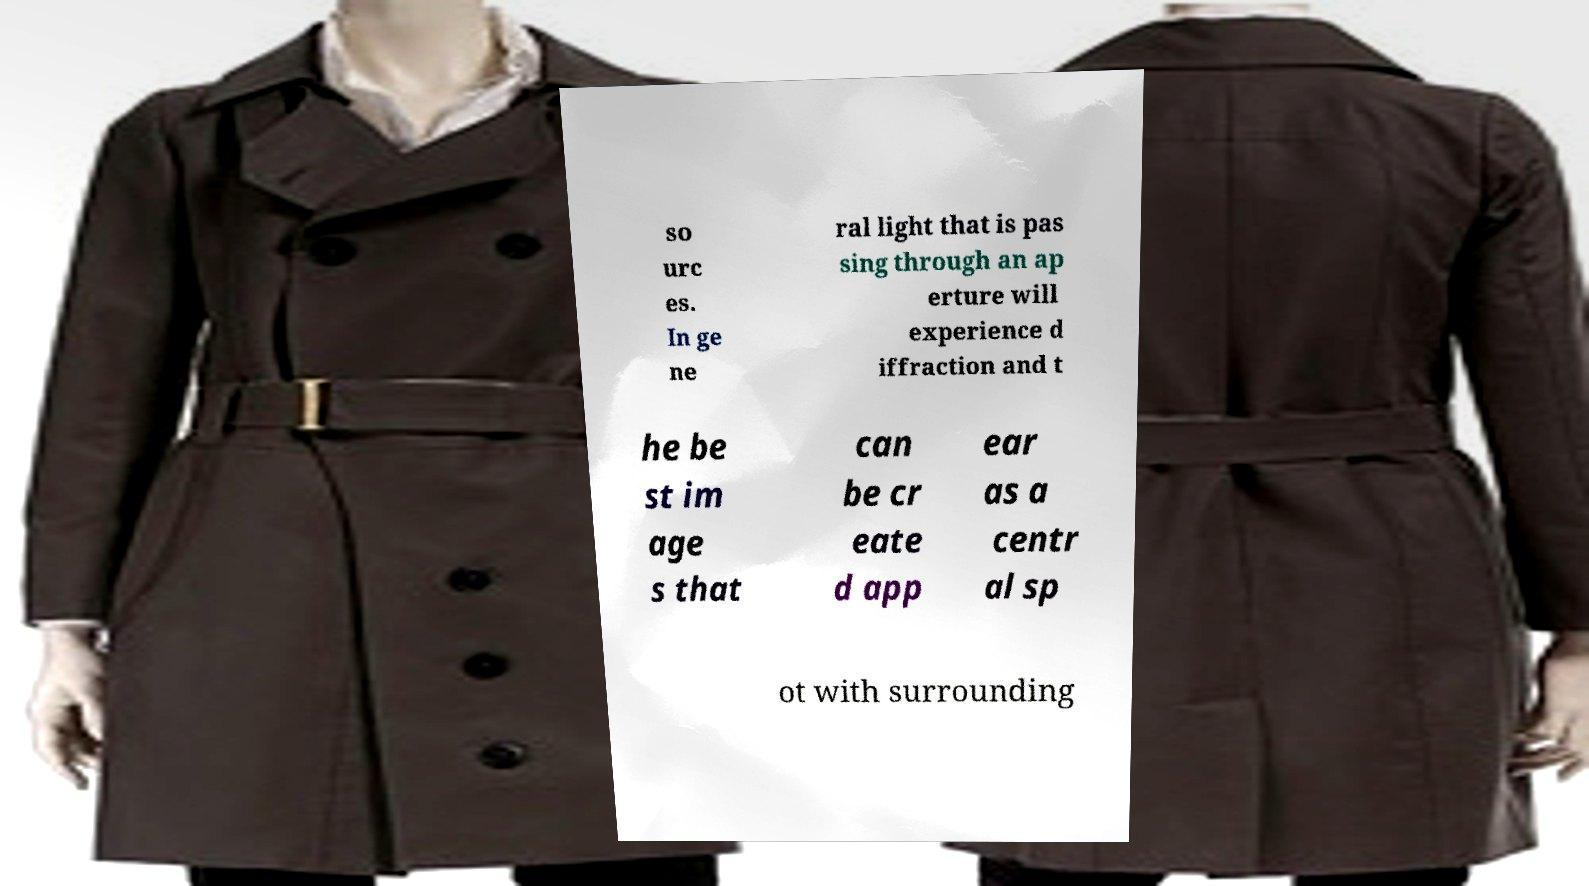For documentation purposes, I need the text within this image transcribed. Could you provide that? so urc es. In ge ne ral light that is pas sing through an ap erture will experience d iffraction and t he be st im age s that can be cr eate d app ear as a centr al sp ot with surrounding 